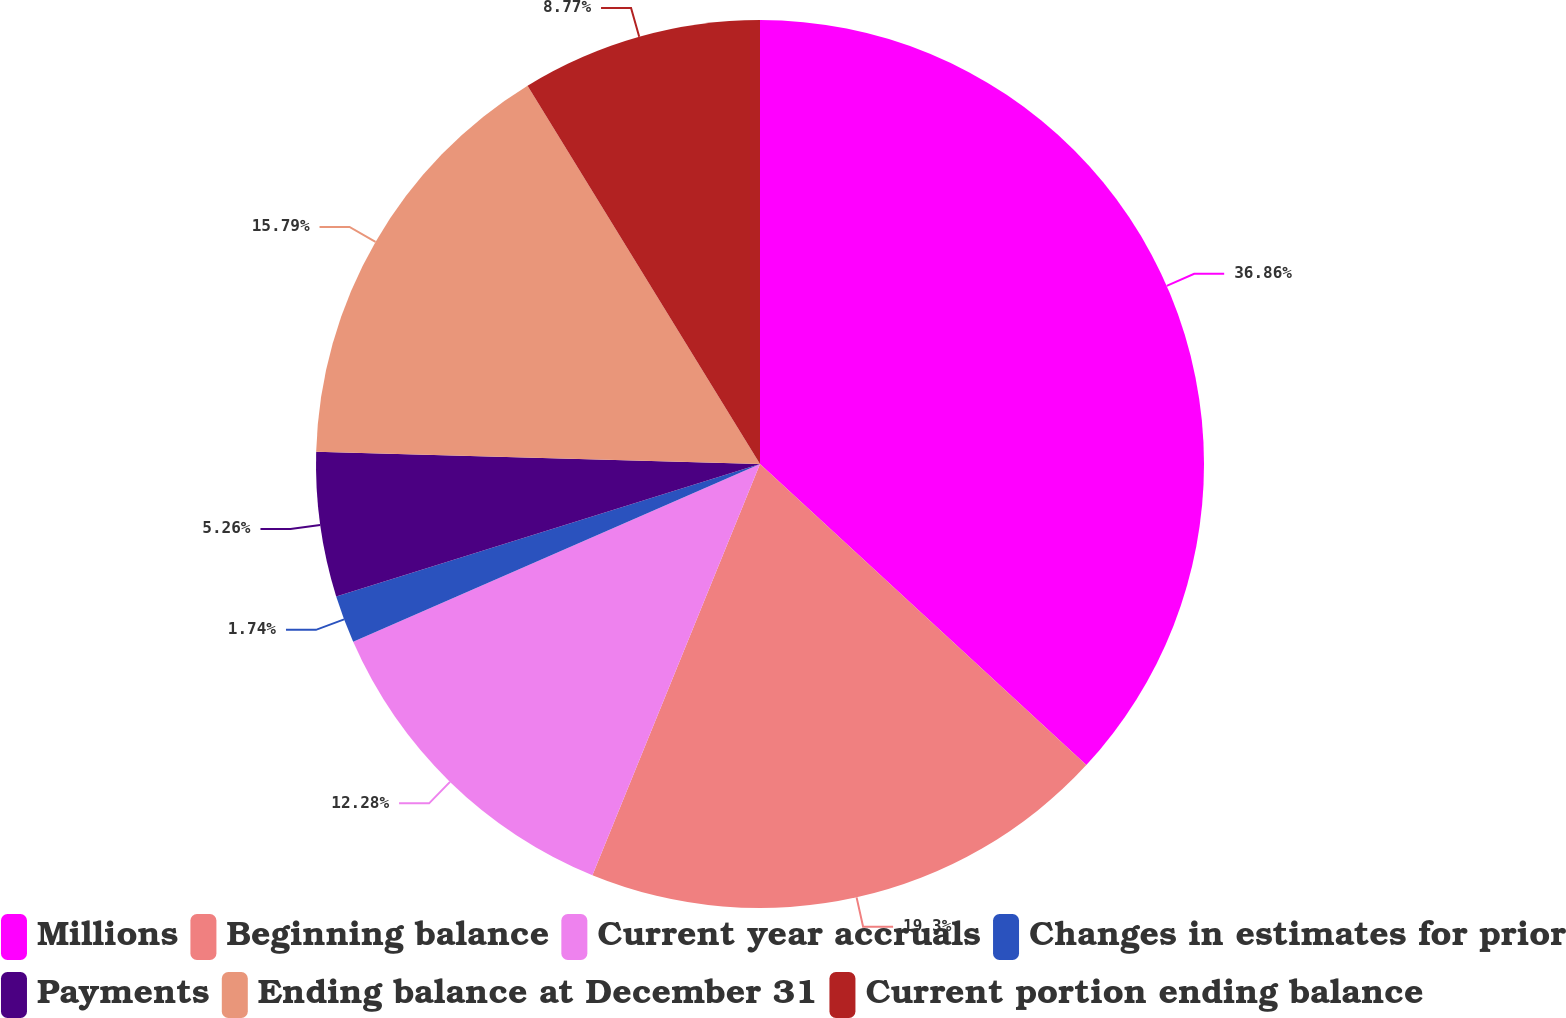Convert chart to OTSL. <chart><loc_0><loc_0><loc_500><loc_500><pie_chart><fcel>Millions<fcel>Beginning balance<fcel>Current year accruals<fcel>Changes in estimates for prior<fcel>Payments<fcel>Ending balance at December 31<fcel>Current portion ending balance<nl><fcel>36.86%<fcel>19.3%<fcel>12.28%<fcel>1.74%<fcel>5.26%<fcel>15.79%<fcel>8.77%<nl></chart> 